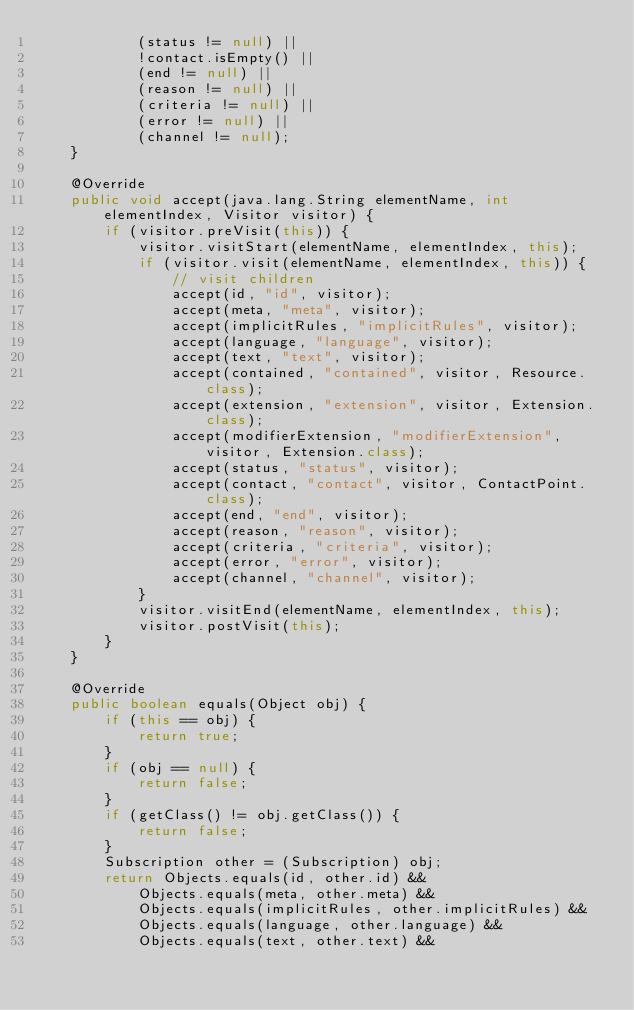<code> <loc_0><loc_0><loc_500><loc_500><_Java_>            (status != null) || 
            !contact.isEmpty() || 
            (end != null) || 
            (reason != null) || 
            (criteria != null) || 
            (error != null) || 
            (channel != null);
    }

    @Override
    public void accept(java.lang.String elementName, int elementIndex, Visitor visitor) {
        if (visitor.preVisit(this)) {
            visitor.visitStart(elementName, elementIndex, this);
            if (visitor.visit(elementName, elementIndex, this)) {
                // visit children
                accept(id, "id", visitor);
                accept(meta, "meta", visitor);
                accept(implicitRules, "implicitRules", visitor);
                accept(language, "language", visitor);
                accept(text, "text", visitor);
                accept(contained, "contained", visitor, Resource.class);
                accept(extension, "extension", visitor, Extension.class);
                accept(modifierExtension, "modifierExtension", visitor, Extension.class);
                accept(status, "status", visitor);
                accept(contact, "contact", visitor, ContactPoint.class);
                accept(end, "end", visitor);
                accept(reason, "reason", visitor);
                accept(criteria, "criteria", visitor);
                accept(error, "error", visitor);
                accept(channel, "channel", visitor);
            }
            visitor.visitEnd(elementName, elementIndex, this);
            visitor.postVisit(this);
        }
    }

    @Override
    public boolean equals(Object obj) {
        if (this == obj) {
            return true;
        }
        if (obj == null) {
            return false;
        }
        if (getClass() != obj.getClass()) {
            return false;
        }
        Subscription other = (Subscription) obj;
        return Objects.equals(id, other.id) && 
            Objects.equals(meta, other.meta) && 
            Objects.equals(implicitRules, other.implicitRules) && 
            Objects.equals(language, other.language) && 
            Objects.equals(text, other.text) && </code> 